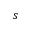Convert formula to latex. <formula><loc_0><loc_0><loc_500><loc_500>s</formula> 